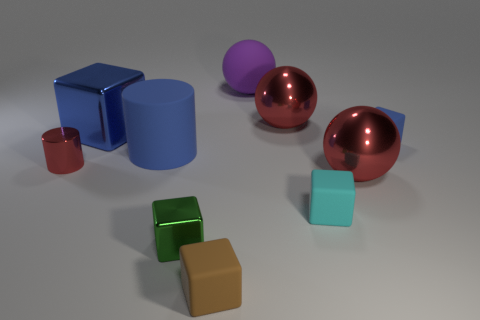There is a cylinder that is the same color as the large block; what is its size?
Provide a short and direct response. Large. Do the large metal block and the small rubber block behind the small red metallic cylinder have the same color?
Make the answer very short. Yes. Do the shiny block behind the tiny metal block and the large rubber cylinder have the same color?
Make the answer very short. Yes. There is a small thing that is the same color as the large cube; what shape is it?
Your response must be concise. Cube. What number of cyan objects are large shiny balls or big cylinders?
Ensure brevity in your answer.  0. Is the number of big blue things that are right of the purple matte object less than the number of small red rubber objects?
Your response must be concise. No. How many tiny green shiny objects are behind the large metallic thing left of the large purple thing?
Provide a short and direct response. 0. How many other things are the same size as the rubber sphere?
Your answer should be very brief. 4. How many objects are large purple cylinders or large red metallic balls behind the tiny blue cube?
Provide a succinct answer. 1. Is the number of big shiny cubes less than the number of small blue metal things?
Provide a succinct answer. No. 